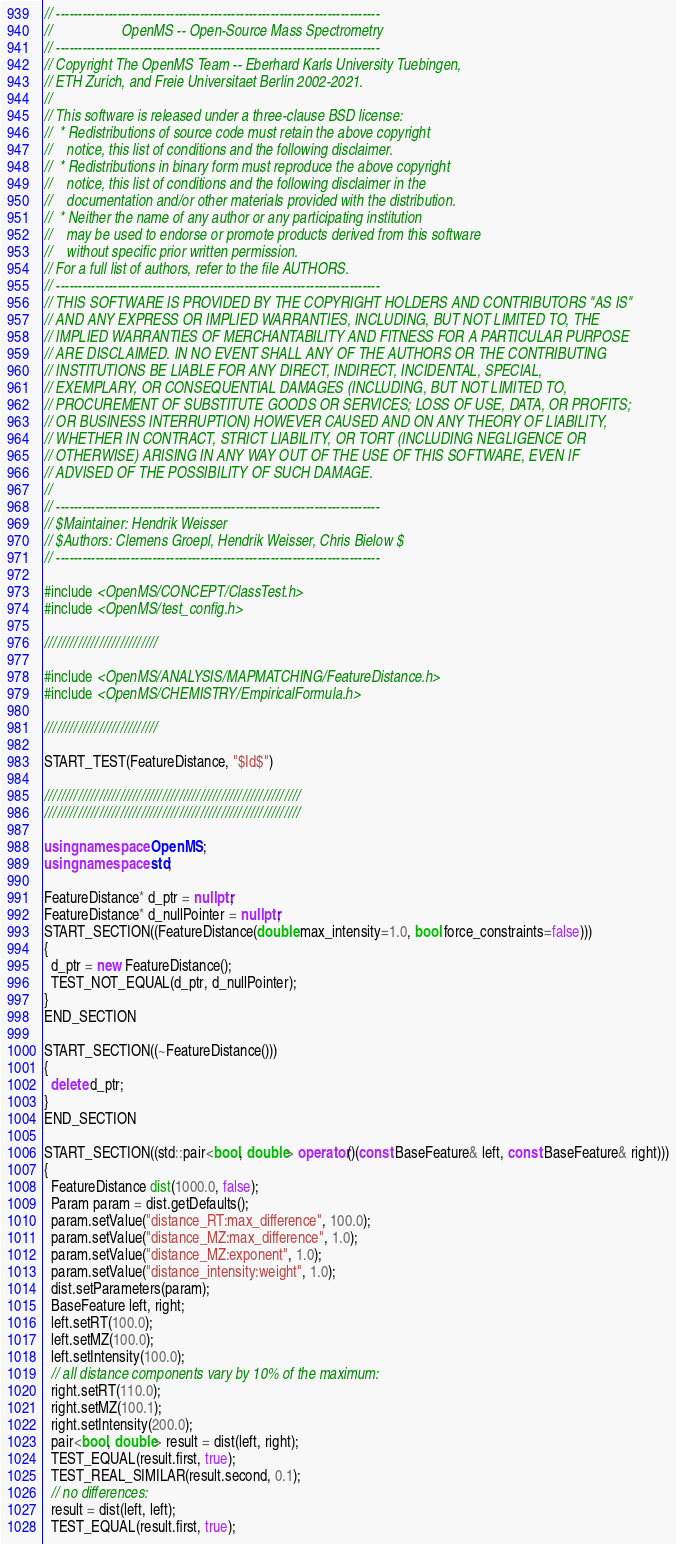<code> <loc_0><loc_0><loc_500><loc_500><_C++_>// --------------------------------------------------------------------------
//                   OpenMS -- Open-Source Mass Spectrometry
// --------------------------------------------------------------------------
// Copyright The OpenMS Team -- Eberhard Karls University Tuebingen,
// ETH Zurich, and Freie Universitaet Berlin 2002-2021.
//
// This software is released under a three-clause BSD license:
//  * Redistributions of source code must retain the above copyright
//    notice, this list of conditions and the following disclaimer.
//  * Redistributions in binary form must reproduce the above copyright
//    notice, this list of conditions and the following disclaimer in the
//    documentation and/or other materials provided with the distribution.
//  * Neither the name of any author or any participating institution
//    may be used to endorse or promote products derived from this software
//    without specific prior written permission.
// For a full list of authors, refer to the file AUTHORS.
// --------------------------------------------------------------------------
// THIS SOFTWARE IS PROVIDED BY THE COPYRIGHT HOLDERS AND CONTRIBUTORS "AS IS"
// AND ANY EXPRESS OR IMPLIED WARRANTIES, INCLUDING, BUT NOT LIMITED TO, THE
// IMPLIED WARRANTIES OF MERCHANTABILITY AND FITNESS FOR A PARTICULAR PURPOSE
// ARE DISCLAIMED. IN NO EVENT SHALL ANY OF THE AUTHORS OR THE CONTRIBUTING
// INSTITUTIONS BE LIABLE FOR ANY DIRECT, INDIRECT, INCIDENTAL, SPECIAL,
// EXEMPLARY, OR CONSEQUENTIAL DAMAGES (INCLUDING, BUT NOT LIMITED TO,
// PROCUREMENT OF SUBSTITUTE GOODS OR SERVICES; LOSS OF USE, DATA, OR PROFITS;
// OR BUSINESS INTERRUPTION) HOWEVER CAUSED AND ON ANY THEORY OF LIABILITY,
// WHETHER IN CONTRACT, STRICT LIABILITY, OR TORT (INCLUDING NEGLIGENCE OR
// OTHERWISE) ARISING IN ANY WAY OUT OF THE USE OF THIS SOFTWARE, EVEN IF
// ADVISED OF THE POSSIBILITY OF SUCH DAMAGE.
//
// --------------------------------------------------------------------------
// $Maintainer: Hendrik Weisser
// $Authors: Clemens Groepl, Hendrik Weisser, Chris Bielow $
// --------------------------------------------------------------------------

#include <OpenMS/CONCEPT/ClassTest.h>
#include <OpenMS/test_config.h>

///////////////////////////

#include <OpenMS/ANALYSIS/MAPMATCHING/FeatureDistance.h>
#include <OpenMS/CHEMISTRY/EmpiricalFormula.h>

///////////////////////////

START_TEST(FeatureDistance, "$Id$")

/////////////////////////////////////////////////////////////
/////////////////////////////////////////////////////////////

using namespace OpenMS;
using namespace std;

FeatureDistance* d_ptr = nullptr;
FeatureDistance* d_nullPointer = nullptr;
START_SECTION((FeatureDistance(double max_intensity=1.0, bool force_constraints=false)))
{
  d_ptr = new FeatureDistance();
  TEST_NOT_EQUAL(d_ptr, d_nullPointer);
}
END_SECTION

START_SECTION((~FeatureDistance()))
{
  delete d_ptr;
}
END_SECTION

START_SECTION((std::pair<bool, double> operator()(const BaseFeature& left, const BaseFeature& right)))
{
  FeatureDistance dist(1000.0, false);
  Param param = dist.getDefaults();
  param.setValue("distance_RT:max_difference", 100.0);
  param.setValue("distance_MZ:max_difference", 1.0);
  param.setValue("distance_MZ:exponent", 1.0);
  param.setValue("distance_intensity:weight", 1.0);
  dist.setParameters(param);
  BaseFeature left, right;
  left.setRT(100.0);
  left.setMZ(100.0);
  left.setIntensity(100.0);
  // all distance components vary by 10% of the maximum:
  right.setRT(110.0);
  right.setMZ(100.1);
  right.setIntensity(200.0);
  pair<bool, double> result = dist(left, right);
  TEST_EQUAL(result.first, true);
  TEST_REAL_SIMILAR(result.second, 0.1);
  // no differences:
  result = dist(left, left);
  TEST_EQUAL(result.first, true);</code> 